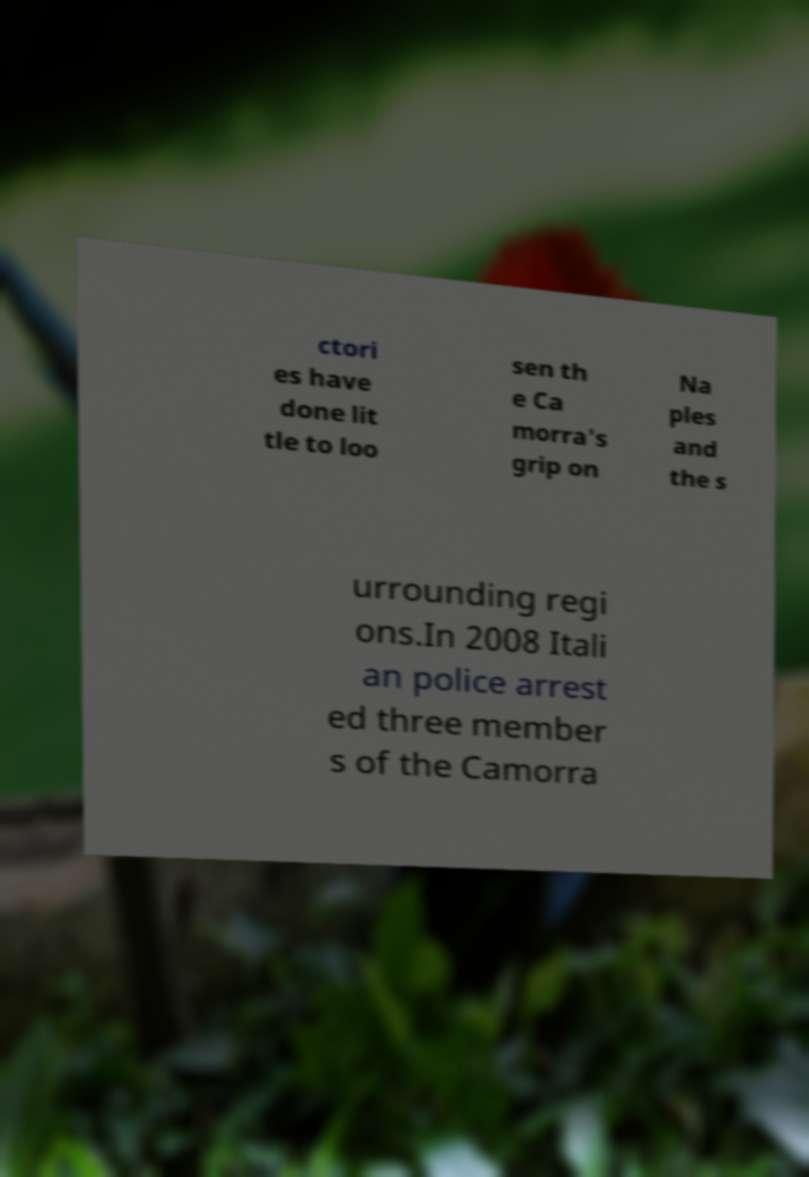Can you accurately transcribe the text from the provided image for me? ctori es have done lit tle to loo sen th e Ca morra's grip on Na ples and the s urrounding regi ons.In 2008 Itali an police arrest ed three member s of the Camorra 